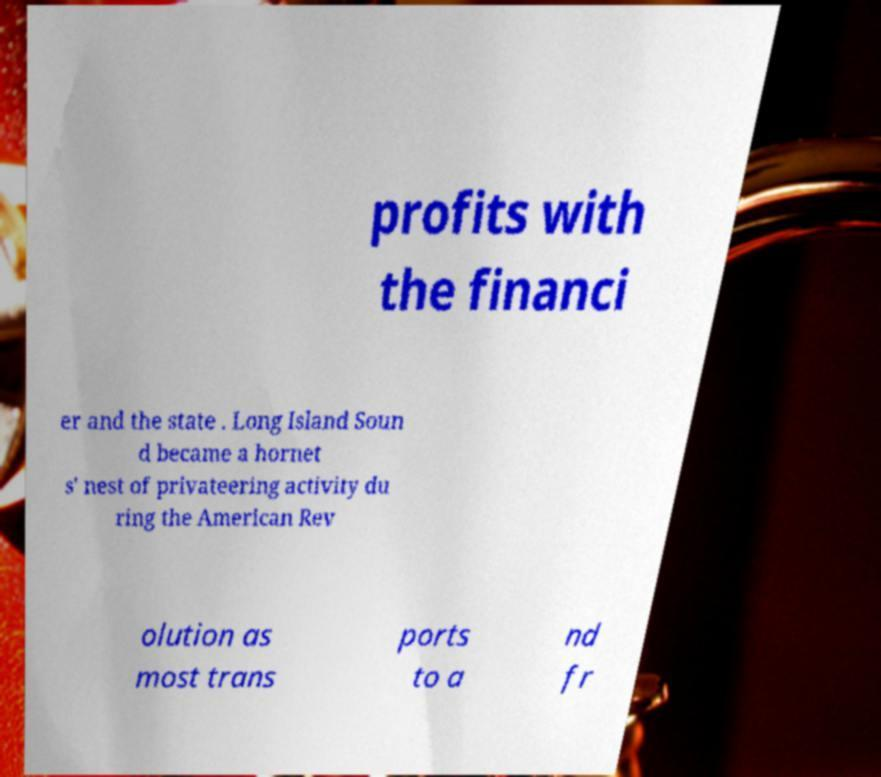For documentation purposes, I need the text within this image transcribed. Could you provide that? profits with the financi er and the state . Long Island Soun d became a hornet s' nest of privateering activity du ring the American Rev olution as most trans ports to a nd fr 